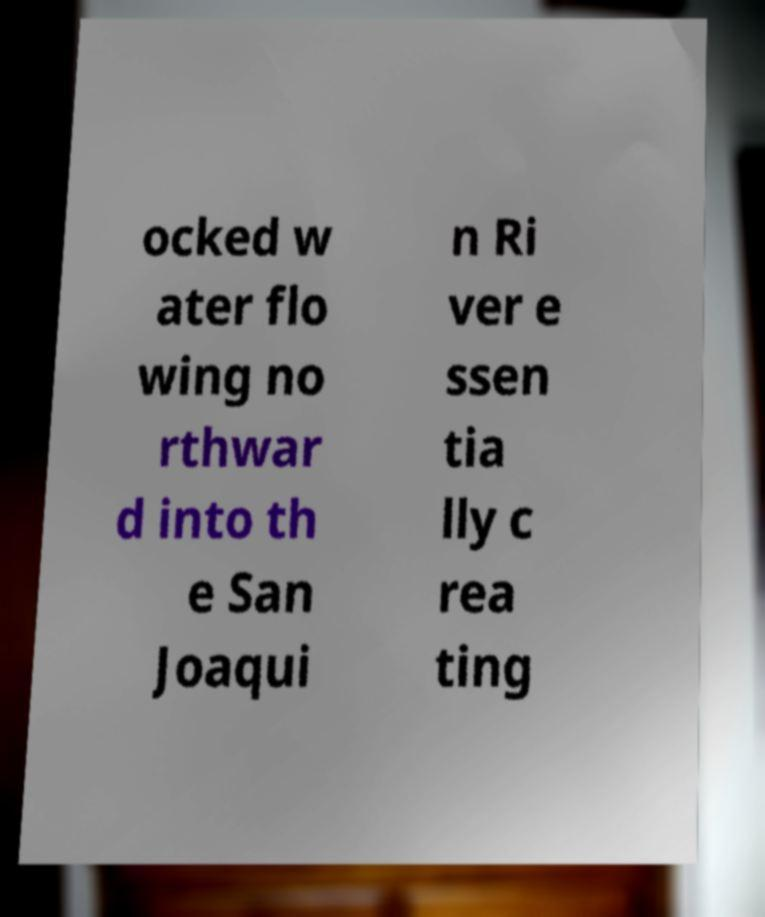I need the written content from this picture converted into text. Can you do that? ocked w ater flo wing no rthwar d into th e San Joaqui n Ri ver e ssen tia lly c rea ting 